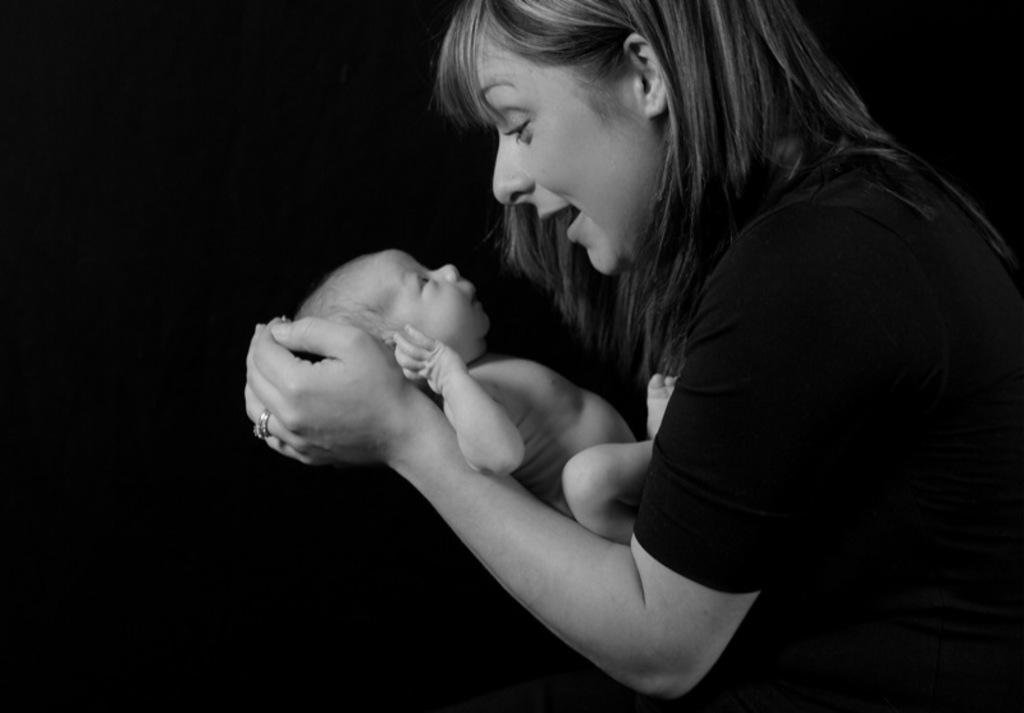What is the main subject of the image? The main subject of the image is a woman. What is the woman doing in the image? The woman is holding a baby in her hand. How many houses can be seen in the image? There are no houses present in the image. What type of transportation is visible in the image? There is no transportation, such as a train, present in the image. What type of toy is the baby holding in the image? The baby is not holding a kite or any other toy in the image. 